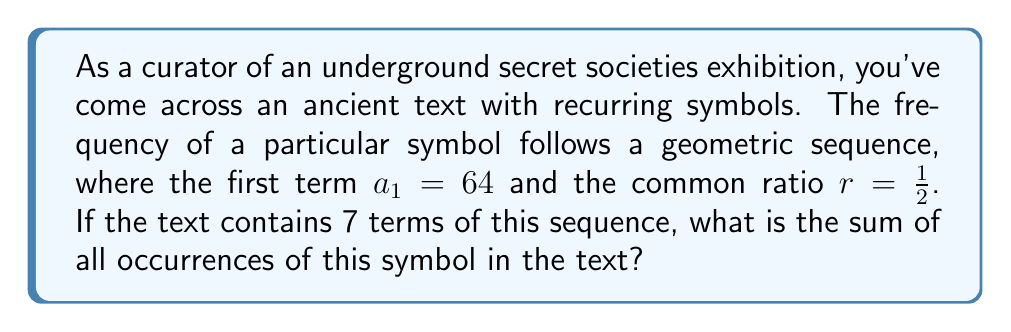Show me your answer to this math problem. To solve this problem, we need to use the formula for the sum of a geometric series:

$$S_n = \frac{a_1(1-r^n)}{1-r}$$

Where:
$S_n$ is the sum of the series
$a_1$ is the first term
$r$ is the common ratio
$n$ is the number of terms

Given:
$a_1 = 64$
$r = \frac{1}{2}$
$n = 7$

Let's substitute these values into the formula:

$$S_7 = \frac{64(1-(\frac{1}{2})^7)}{1-\frac{1}{2}}$$

Simplify the numerator:
$$S_7 = \frac{64(1-\frac{1}{128})}{1-\frac{1}{2}} = \frac{64(\frac{127}{128})}{\frac{1}{2}}$$

Multiply the fractions:
$$S_7 = 64 \cdot \frac{127}{128} \cdot 2 = 127$$

Therefore, the sum of all occurrences of this symbol in the text is 127.
Answer: 127 